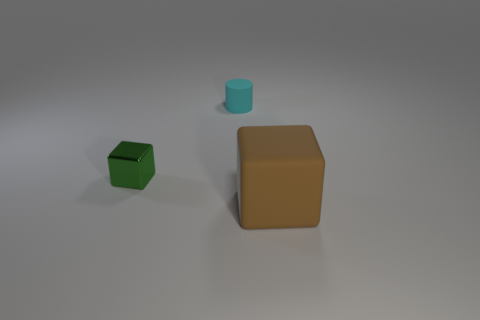Add 2 small cyan matte things. How many objects exist? 5 Subtract all cubes. How many objects are left? 1 Subtract 0 brown cylinders. How many objects are left? 3 Subtract all small objects. Subtract all tiny metallic things. How many objects are left? 0 Add 1 small green metallic blocks. How many small green metallic blocks are left? 2 Add 3 small cyan matte things. How many small cyan matte things exist? 4 